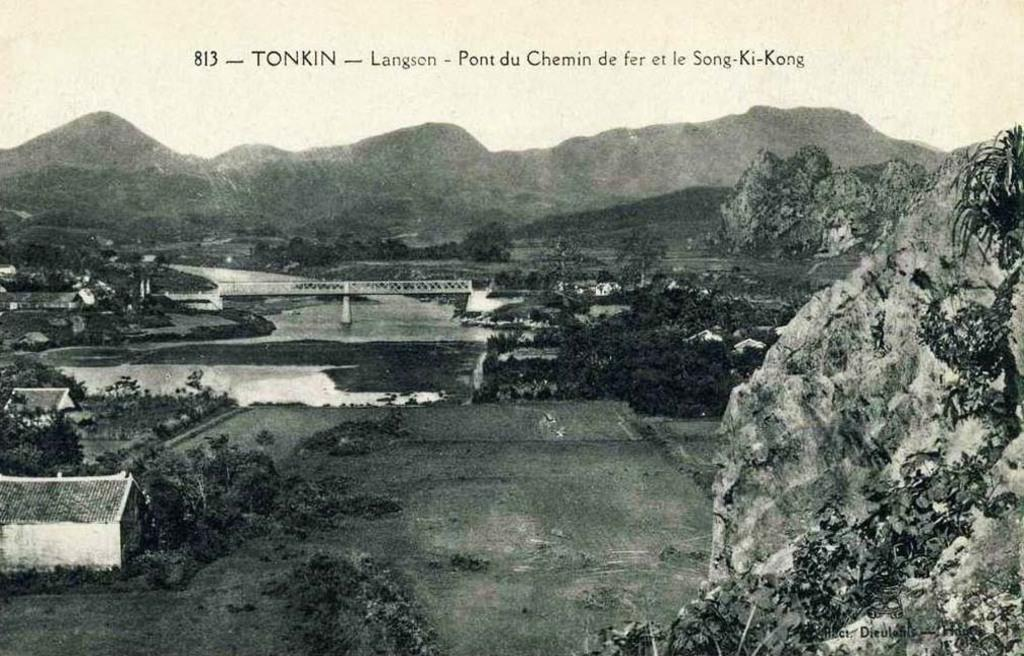What is the color scheme of the image? The image is black and white. What can be seen on the right side of the image? There is a rock on the right side of the image. What is visible in the background of the image? There are houses, trees, water, and a bridge in the background of the image. Can you describe the text visible at the top of the image? Unfortunately, the provided facts do not give any information about the text, so we cannot describe it. How many straws are floating in the water in the image? There are no straws visible in the image; it only shows a rock, houses, trees, water, and a bridge in the background. --- Facts: 1. There is a person sitting on a chair in the image. 2. The person is holding a book. 3. There is a table next to the chair. 4. There is a lamp on the table. 5. The background of the image is dark. Absurd Topics: parrot, bicycle, ocean Conversation: What is the person in the image doing? The person is sitting on a chair in the image. What is the person holding in the image? The person is holding a book. What is located next to the chair in the image? There is a table next to the chair in the image. What is on the table in the image? There is a lamp on the table in the image. Can you describe the background of the image? The background of the image is dark. Reasoning: Let's think step by step in order to produce the conversation. We start by identifying the main subject in the image, which is the person sitting on a chair. Then, we describe what the person is holding, which is a book. Next, we expand the conversation to include the table and lamp next to the chair. Finally, we describe the background of the image, which is dark. Absurd Question/Answer: Can you tell me how many parrots are sitting on the bicycle in the image? There are no parrots or bicycles present in the image; it only shows a person sitting on a chair, holding a book, and a table with a lamp. --- Facts: 1. There is a car in the image. 2. The car is red. 3. There are people in the car. 4. The car has four wheels. 5. The car has a license plate. Absurd Topics: snow, umbrella, piano Conversation: What is the main subject of the image? The main subject of the image is a car. What color is the car? The car is red. 